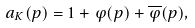Convert formula to latex. <formula><loc_0><loc_0><loc_500><loc_500>a _ { K } ( p ) = 1 + \varphi ( p ) + \overline { \varphi } ( p ) ,</formula> 